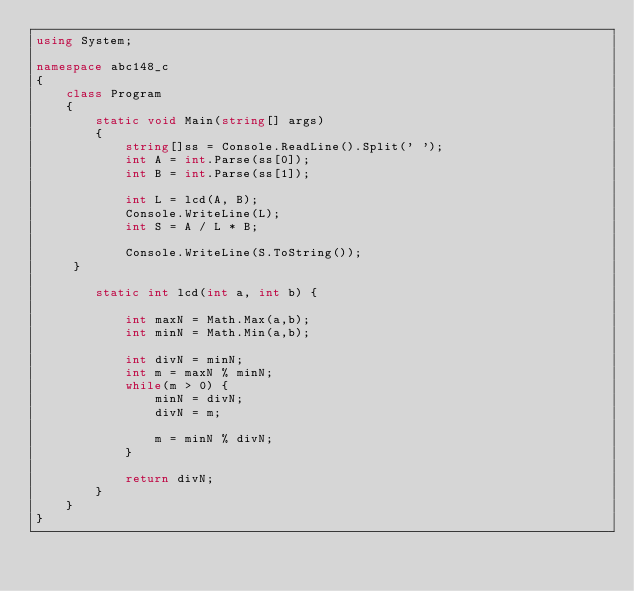Convert code to text. <code><loc_0><loc_0><loc_500><loc_500><_C#_>using System;

namespace abc148_c
{
    class Program
    {
        static void Main(string[] args)
        {
            string[]ss = Console.ReadLine().Split(' ');
            int A = int.Parse(ss[0]);
            int B = int.Parse(ss[1]);

            int L = lcd(A, B);
            Console.WriteLine(L);
            int S = A / L * B;

            Console.WriteLine(S.ToString());
     }

        static int lcd(int a, int b) {

            int maxN = Math.Max(a,b);
            int minN = Math.Min(a,b);

            int divN = minN;
            int m = maxN % minN;
            while(m > 0) {
                minN = divN;
                divN = m;

                m = minN % divN; 
            }

            return divN;
        }
    }
}
</code> 